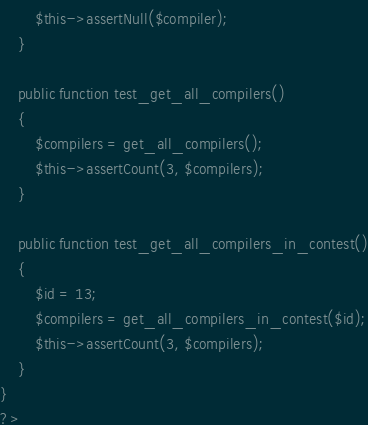<code> <loc_0><loc_0><loc_500><loc_500><_PHP_>		$this->assertNull($compiler);
	}

	public function test_get_all_compilers()
	{
		$compilers = get_all_compilers();
		$this->assertCount(3, $compilers);
	}

	public function test_get_all_compilers_in_contest()
	{
		$id = 13;
		$compilers = get_all_compilers_in_contest($id);
		$this->assertCount(3, $compilers);
	}
}
?>
</code> 